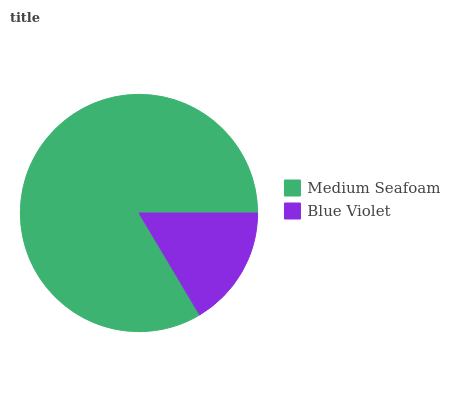Is Blue Violet the minimum?
Answer yes or no. Yes. Is Medium Seafoam the maximum?
Answer yes or no. Yes. Is Blue Violet the maximum?
Answer yes or no. No. Is Medium Seafoam greater than Blue Violet?
Answer yes or no. Yes. Is Blue Violet less than Medium Seafoam?
Answer yes or no. Yes. Is Blue Violet greater than Medium Seafoam?
Answer yes or no. No. Is Medium Seafoam less than Blue Violet?
Answer yes or no. No. Is Medium Seafoam the high median?
Answer yes or no. Yes. Is Blue Violet the low median?
Answer yes or no. Yes. Is Blue Violet the high median?
Answer yes or no. No. Is Medium Seafoam the low median?
Answer yes or no. No. 